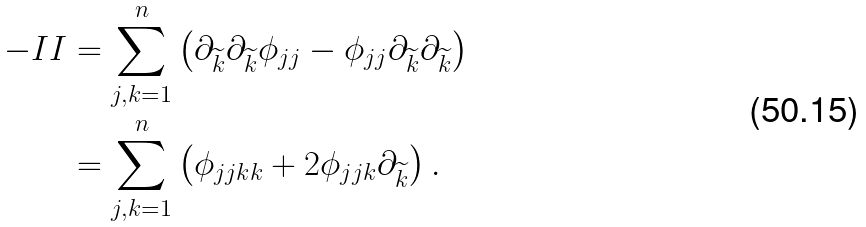<formula> <loc_0><loc_0><loc_500><loc_500>- I I & = \sum _ { j , k = 1 } ^ { n } \left ( \partial _ { \widetilde { k } } \partial _ { \widetilde { k } } \phi _ { j j } - \phi _ { j j } \partial _ { \widetilde { k } } \partial _ { \widetilde { k } } \right ) \\ & = \sum _ { j , k = 1 } ^ { n } \left ( \phi _ { j j k k } + 2 \phi _ { j j k } \partial _ { \widetilde { k } } \right ) .</formula> 